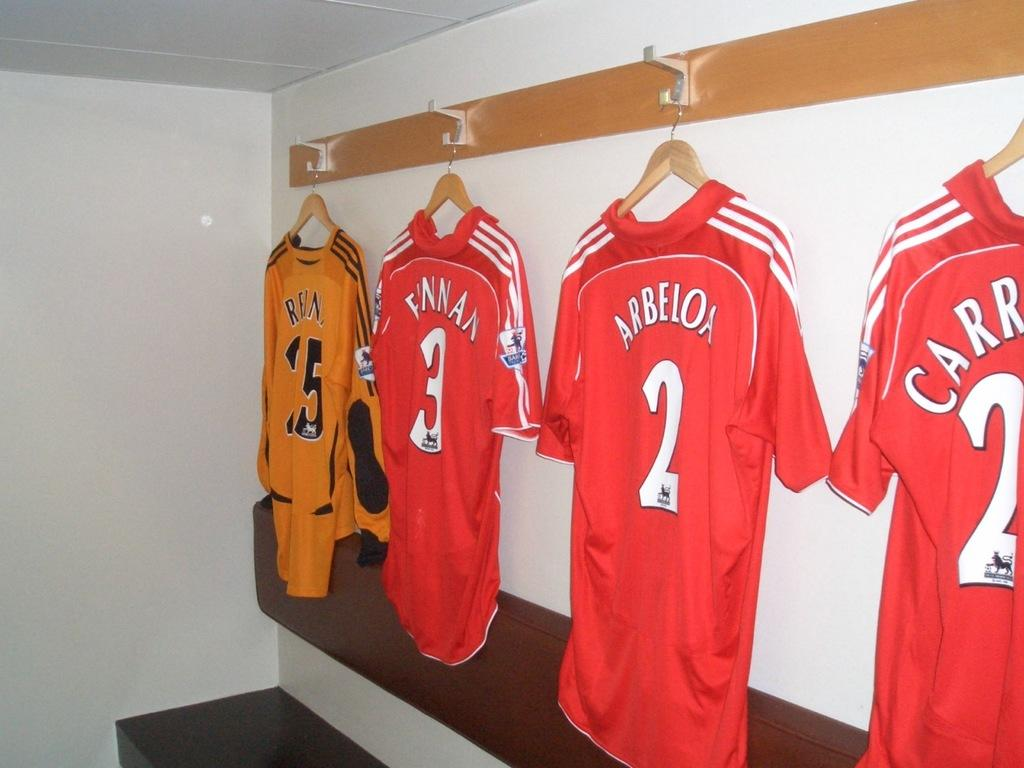<image>
Relay a brief, clear account of the picture shown. red jerseys with the names arbeloa carr and finnan 